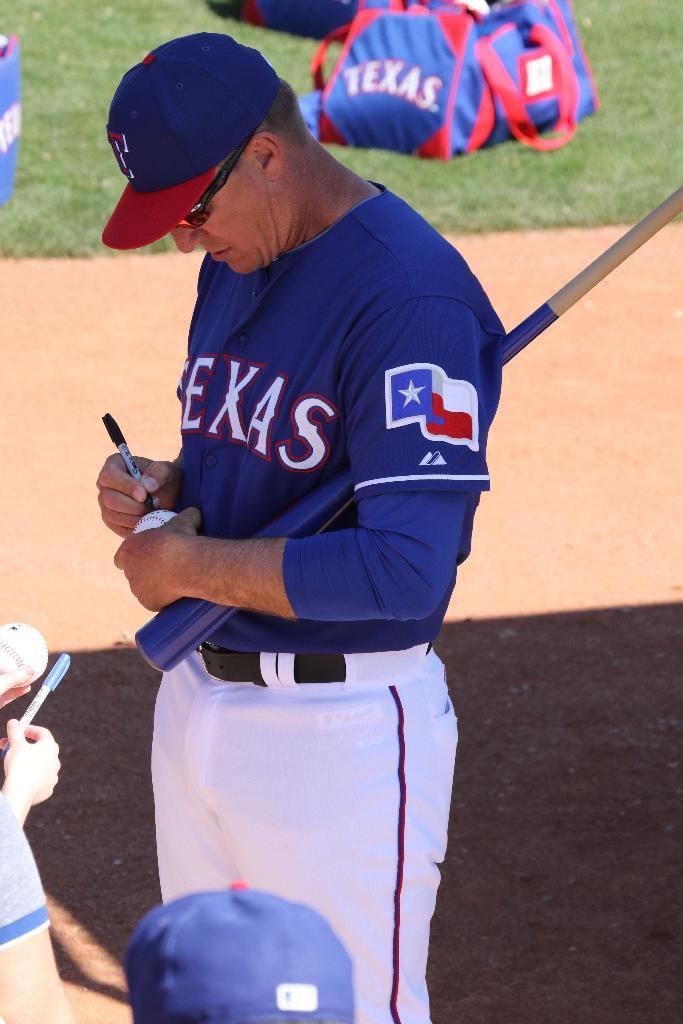<image>
Share a concise interpretation of the image provided. Texas baseball player autographing a fan's baseball with a marker. 